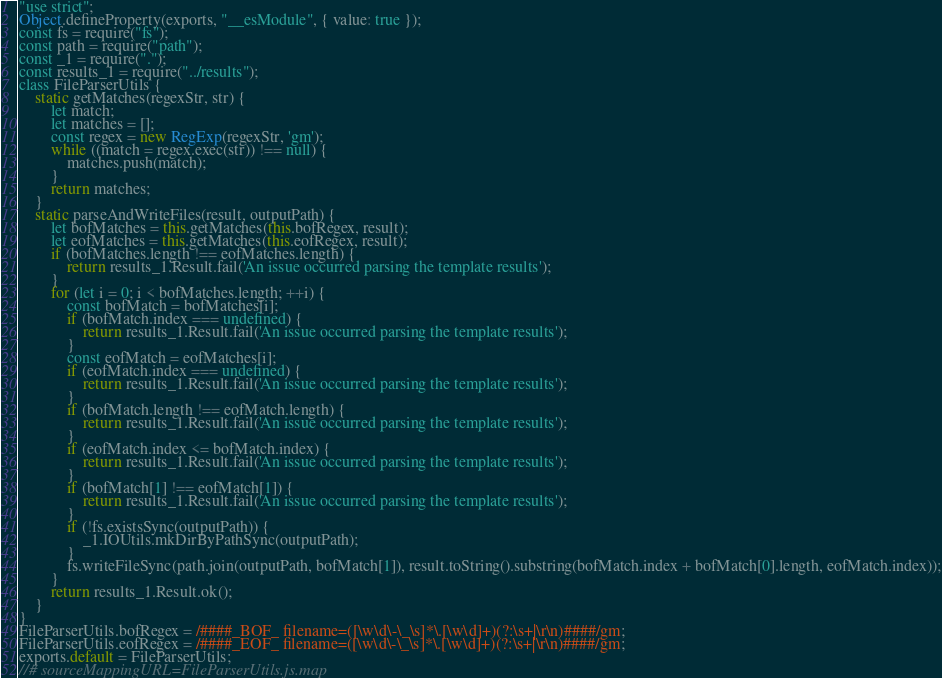<code> <loc_0><loc_0><loc_500><loc_500><_JavaScript_>"use strict";
Object.defineProperty(exports, "__esModule", { value: true });
const fs = require("fs");
const path = require("path");
const _1 = require(".");
const results_1 = require("../results");
class FileParserUtils {
    static getMatches(regexStr, str) {
        let match;
        let matches = [];
        const regex = new RegExp(regexStr, 'gm');
        while ((match = regex.exec(str)) !== null) {
            matches.push(match);
        }
        return matches;
    }
    static parseAndWriteFiles(result, outputPath) {
        let bofMatches = this.getMatches(this.bofRegex, result);
        let eofMatches = this.getMatches(this.eofRegex, result);
        if (bofMatches.length !== eofMatches.length) {
            return results_1.Result.fail('An issue occurred parsing the template results');
        }
        for (let i = 0; i < bofMatches.length; ++i) {
            const bofMatch = bofMatches[i];
            if (bofMatch.index === undefined) {
                return results_1.Result.fail('An issue occurred parsing the template results');
            }
            const eofMatch = eofMatches[i];
            if (eofMatch.index === undefined) {
                return results_1.Result.fail('An issue occurred parsing the template results');
            }
            if (bofMatch.length !== eofMatch.length) {
                return results_1.Result.fail('An issue occurred parsing the template results');
            }
            if (eofMatch.index <= bofMatch.index) {
                return results_1.Result.fail('An issue occurred parsing the template results');
            }
            if (bofMatch[1] !== eofMatch[1]) {
                return results_1.Result.fail('An issue occurred parsing the template results');
            }
            if (!fs.existsSync(outputPath)) {
                _1.IOUtils.mkDirByPathSync(outputPath);
            }
            fs.writeFileSync(path.join(outputPath, bofMatch[1]), result.toString().substring(bofMatch.index + bofMatch[0].length, eofMatch.index));
        }
        return results_1.Result.ok();
    }
}
FileParserUtils.bofRegex = /####_BOF_ filename=([\w\d\-\_\s]*\.[\w\d]+)(?:\s+|\r\n)####/gm;
FileParserUtils.eofRegex = /####_EOF_ filename=([\w\d\-\_\s]*\.[\w\d]+)(?:\s+|\r\n)####/gm;
exports.default = FileParserUtils;
//# sourceMappingURL=FileParserUtils.js.map</code> 